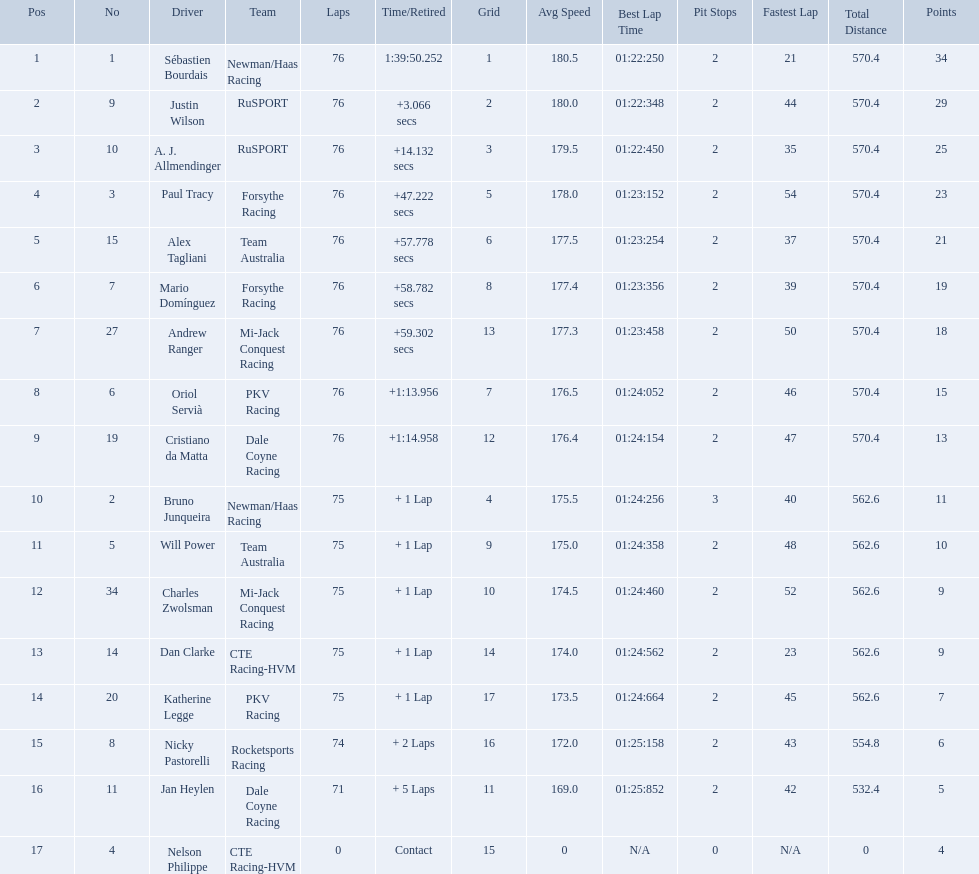Is there a driver named charles zwolsman? Charles Zwolsman. How many points did he acquire? 9. Were there any other entries that got the same number of points? 9. Who did that entry belong to? Dan Clarke. 